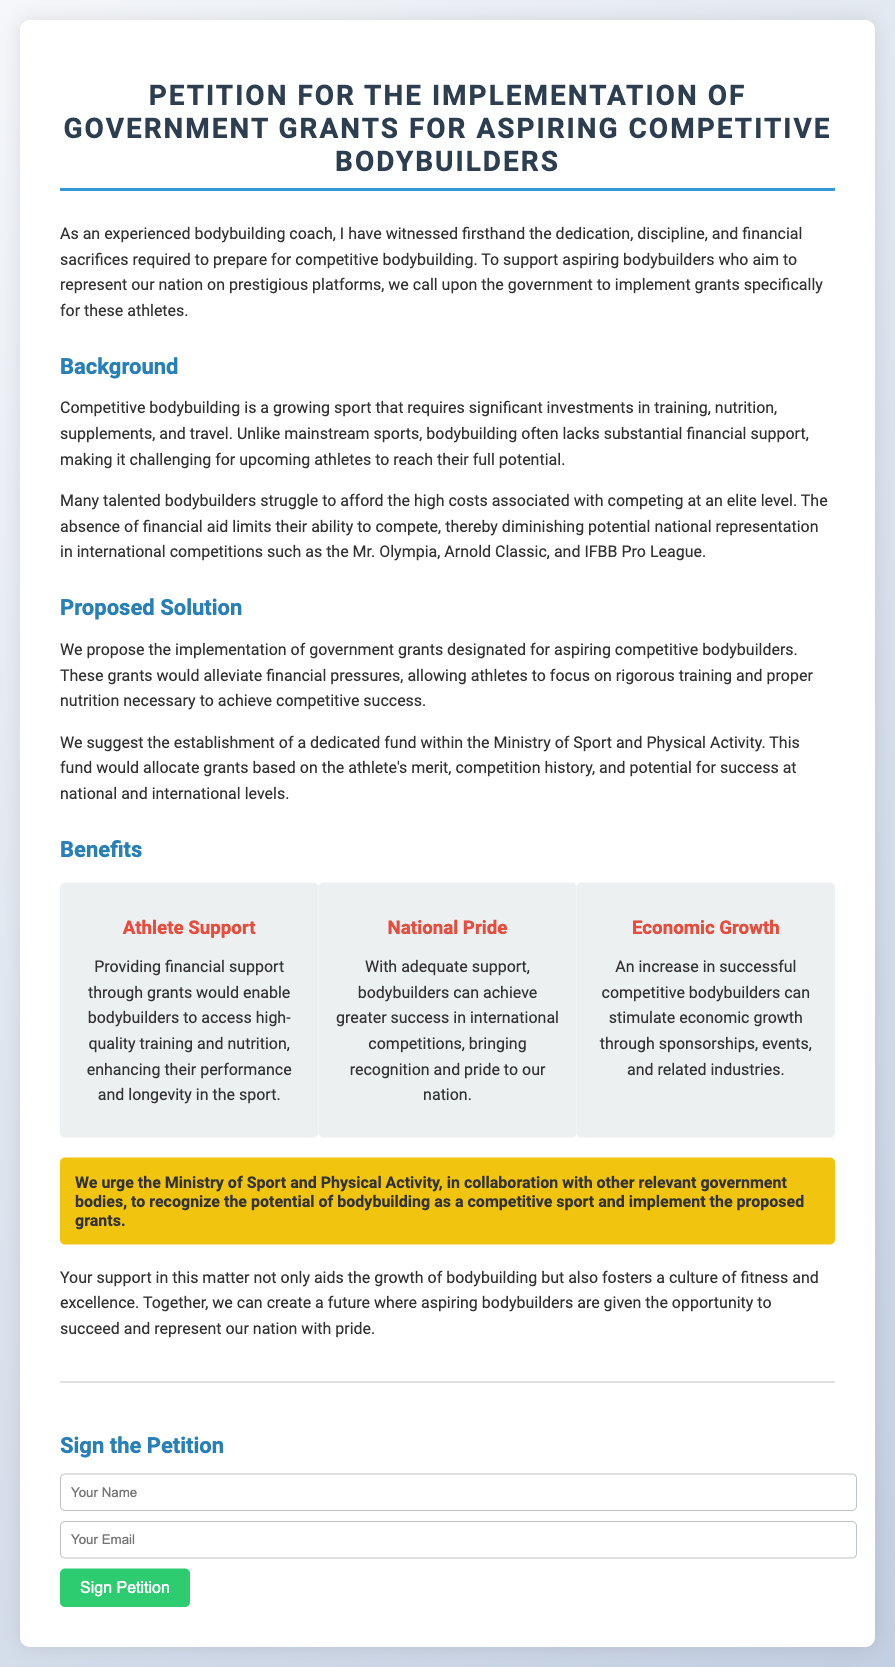What is the title of the petition? The title of the petition is prominently displayed at the top of the document.
Answer: Petition for the Implementation of Government Grants for Aspiring Competitive Bodybuilders What is the primary proposal of the petition? The primary proposal is listed in the "Proposed Solution" section of the document.
Answer: Implementation of government grants Who is urged to recognize the potential of bodybuilding? The specific entity urged is mentioned in the "highlight" section of the document.
Answer: Ministry of Sport and Physical Activity What are the three benefits listed in the petition? The benefits are detailed in the "Benefits" section, where each benefit is summarized.
Answer: Athlete Support, National Pride, Economic Growth What type of support do the petitioners seek? The type of support is also clearly stated in the "Proposed Solution" section.
Answer: Financial support through grants How many benefit items are mentioned? The number of benefit items corresponds to the sections highlighted under "Benefits."
Answer: Three What is the intended use for the grants? The intended use for the grants is outlined in the "Proposed Solution" section.
Answer: Alleviate financial pressures What impacts does the petition claim successful bodybuilders could have? The impacts are described in the "Economic Growth" benefit item.
Answer: Stimulate economic growth What action does the petition encourage individuals to take? The specific action requested from individuals is included at the bottom of the document.
Answer: Sign the Petition 